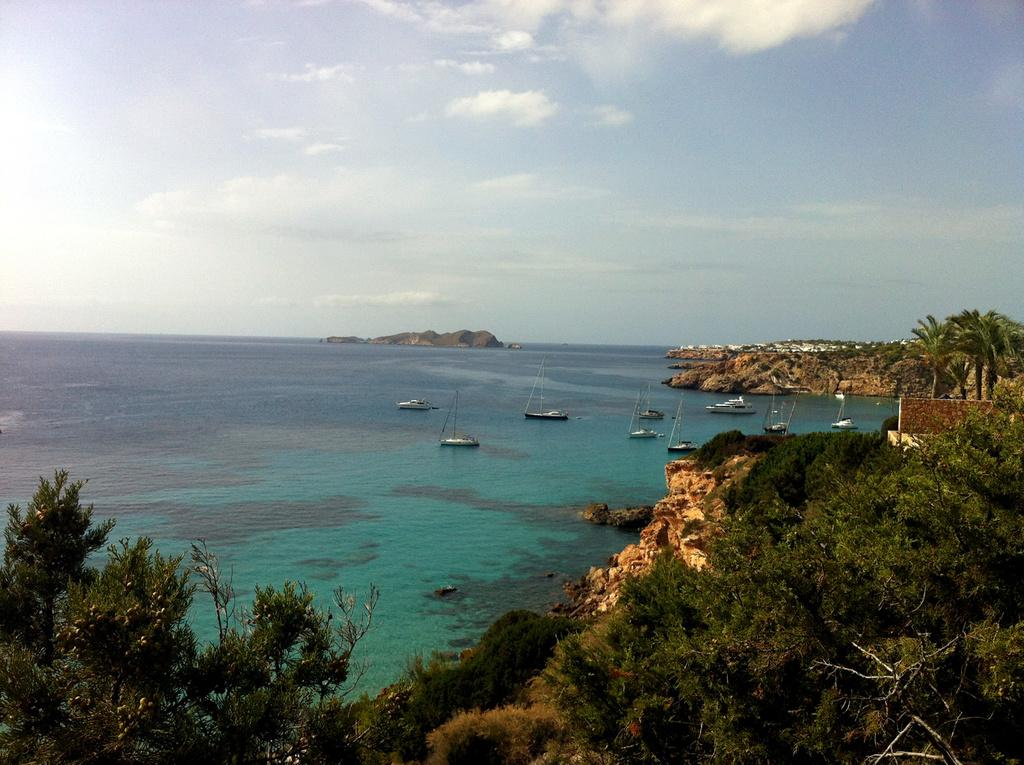What type of natural features can be seen in the image? There are trees and mountains in the image. What is visible in the water in the image? There are boats in the water. What is visible at the top of the image? The sky is visible at the top of the image. Can you describe the possible location of the image? The image may have been taken near the ocean. What type of produce is being sold at the camp in the image? There is no camp or produce present in the image. What type of art can be seen on the mountains in the image? There is no art visible on the mountains in the image. 